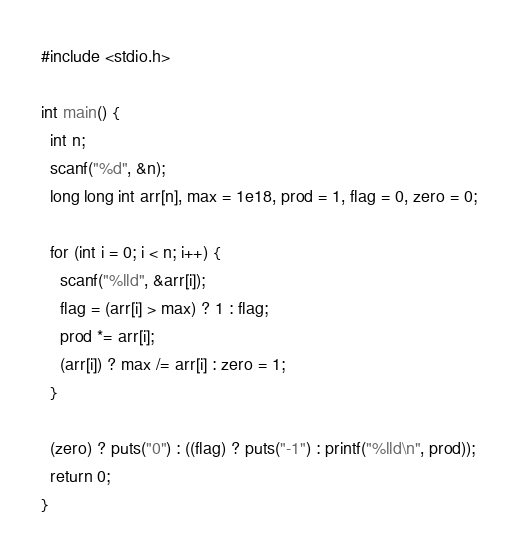<code> <loc_0><loc_0><loc_500><loc_500><_C#_>#include <stdio.h>

int main() {
  int n;
  scanf("%d", &n);
  long long int arr[n], max = 1e18, prod = 1, flag = 0, zero = 0;
  
  for (int i = 0; i < n; i++) {
    scanf("%lld", &arr[i]);
    flag = (arr[i] > max) ? 1 : flag;
    prod *= arr[i];
    (arr[i]) ? max /= arr[i] : zero = 1;
  }

  (zero) ? puts("0") : ((flag) ? puts("-1") : printf("%lld\n", prod));
  return 0;
}
</code> 